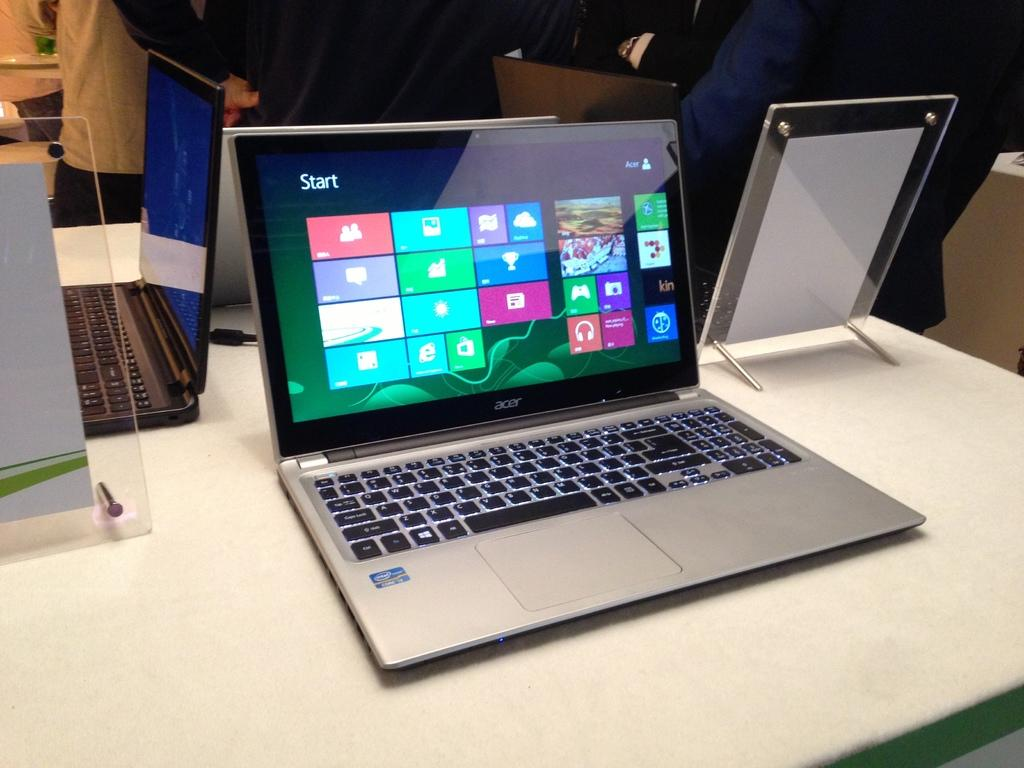Provide a one-sentence caption for the provided image. Acer laptop that has a screen showing the Start panel. 